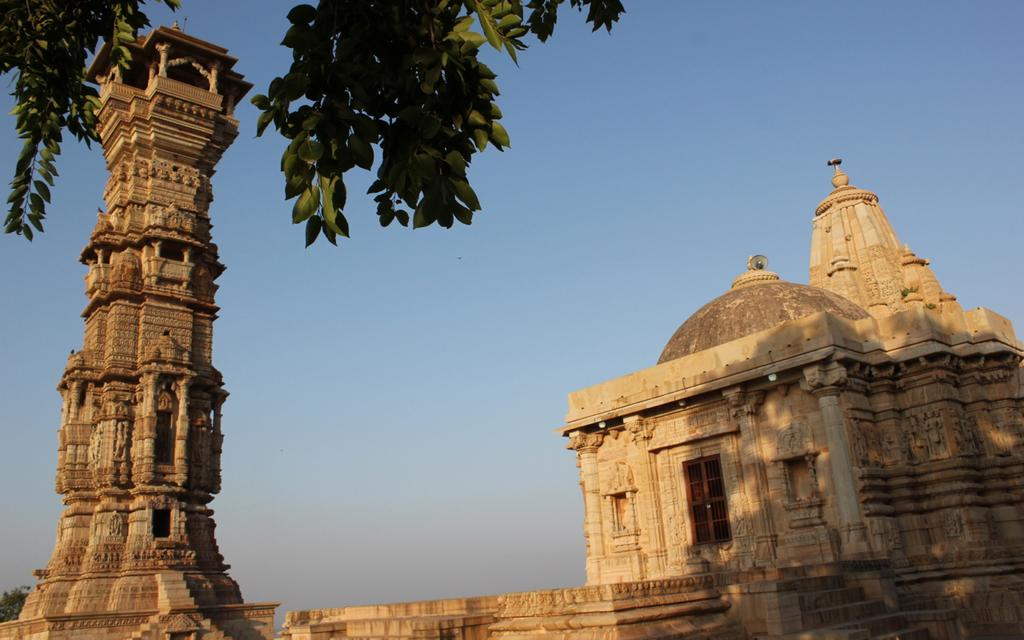What color is the sky in the image? The sky is blue in the image. What type of vegetation is present in the image? There are green leaves in the image. What architectural feature can be seen in the image? There is a stone carved pillar in the image. What type of building is depicted in the image? There is a castle in the image. How many pairs of shoes can be seen on the zebra in the image? There is no zebra or shoes present in the image. What type of holiday is being celebrated in the image? There is no indication of a holiday being celebrated in the image. 